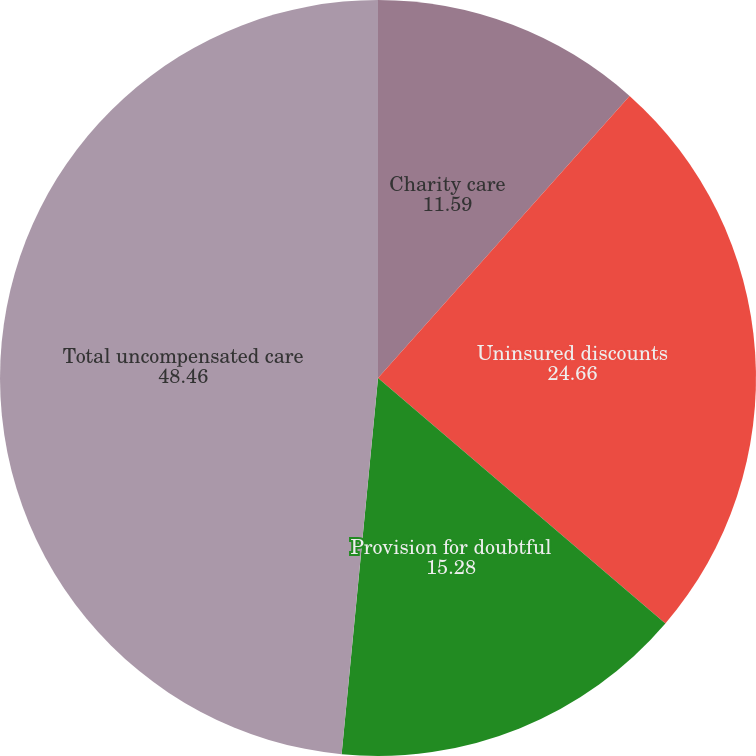Convert chart. <chart><loc_0><loc_0><loc_500><loc_500><pie_chart><fcel>Charity care<fcel>Uninsured discounts<fcel>Provision for doubtful<fcel>Total uncompensated care<nl><fcel>11.59%<fcel>24.66%<fcel>15.28%<fcel>48.46%<nl></chart> 